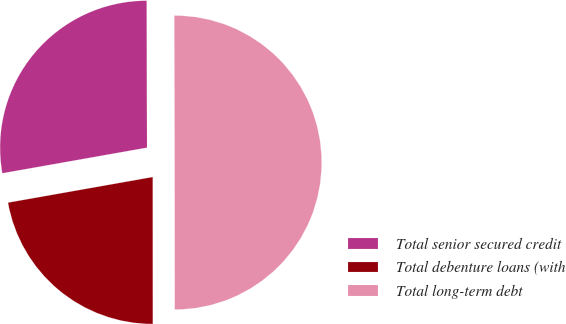<chart> <loc_0><loc_0><loc_500><loc_500><pie_chart><fcel>Total senior secured credit<fcel>Total debenture loans (with<fcel>Total long-term debt<nl><fcel>27.75%<fcel>22.22%<fcel>50.03%<nl></chart> 